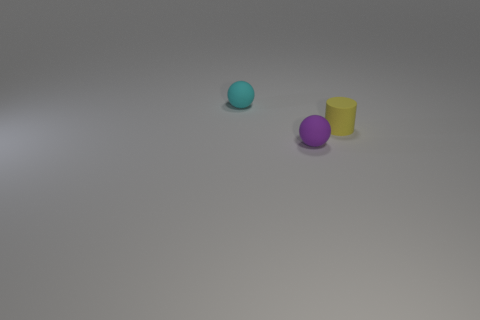Add 2 tiny green objects. How many objects exist? 5 Subtract all cylinders. How many objects are left? 2 Subtract 0 cyan cylinders. How many objects are left? 3 Subtract all cylinders. Subtract all small cyan matte objects. How many objects are left? 1 Add 3 cylinders. How many cylinders are left? 4 Add 3 small cylinders. How many small cylinders exist? 4 